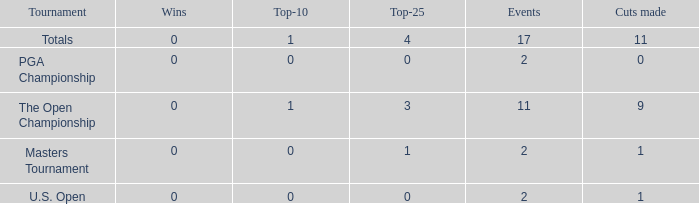What is his highest number of top 25s when eh played over 2 events and under 0 wins? None. Could you help me parse every detail presented in this table? {'header': ['Tournament', 'Wins', 'Top-10', 'Top-25', 'Events', 'Cuts made'], 'rows': [['Totals', '0', '1', '4', '17', '11'], ['PGA Championship', '0', '0', '0', '2', '0'], ['The Open Championship', '0', '1', '3', '11', '9'], ['Masters Tournament', '0', '0', '1', '2', '1'], ['U.S. Open', '0', '0', '0', '2', '1']]} 